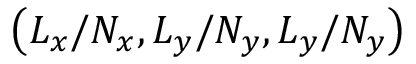<formula> <loc_0><loc_0><loc_500><loc_500>\left ( L _ { x } / N _ { x } , L _ { y } / N _ { y } , L _ { y } / N _ { y } \right )</formula> 